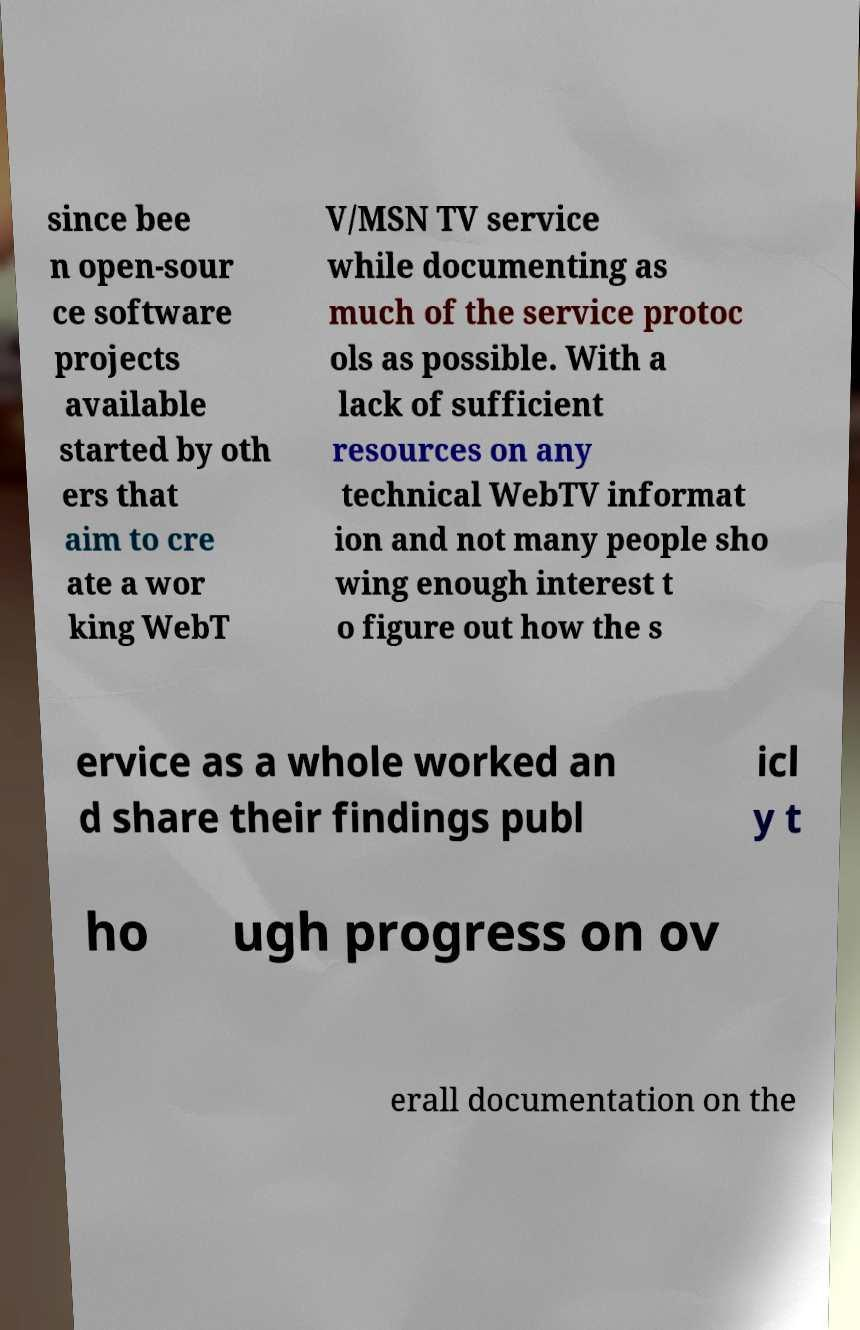Could you extract and type out the text from this image? since bee n open-sour ce software projects available started by oth ers that aim to cre ate a wor king WebT V/MSN TV service while documenting as much of the service protoc ols as possible. With a lack of sufficient resources on any technical WebTV informat ion and not many people sho wing enough interest t o figure out how the s ervice as a whole worked an d share their findings publ icl y t ho ugh progress on ov erall documentation on the 